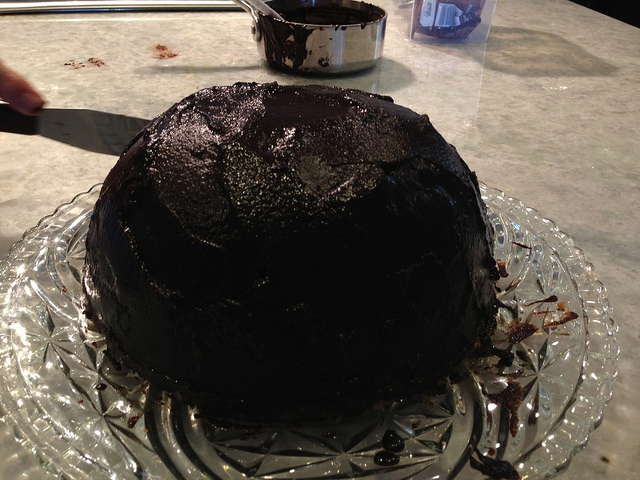Describe the objects in this image and their specific colors. I can see cake in gray and black tones, dining table in gray and tan tones, bowl in gray and black tones, knife in gray and black tones, and people in gray, maroon, black, and brown tones in this image. 